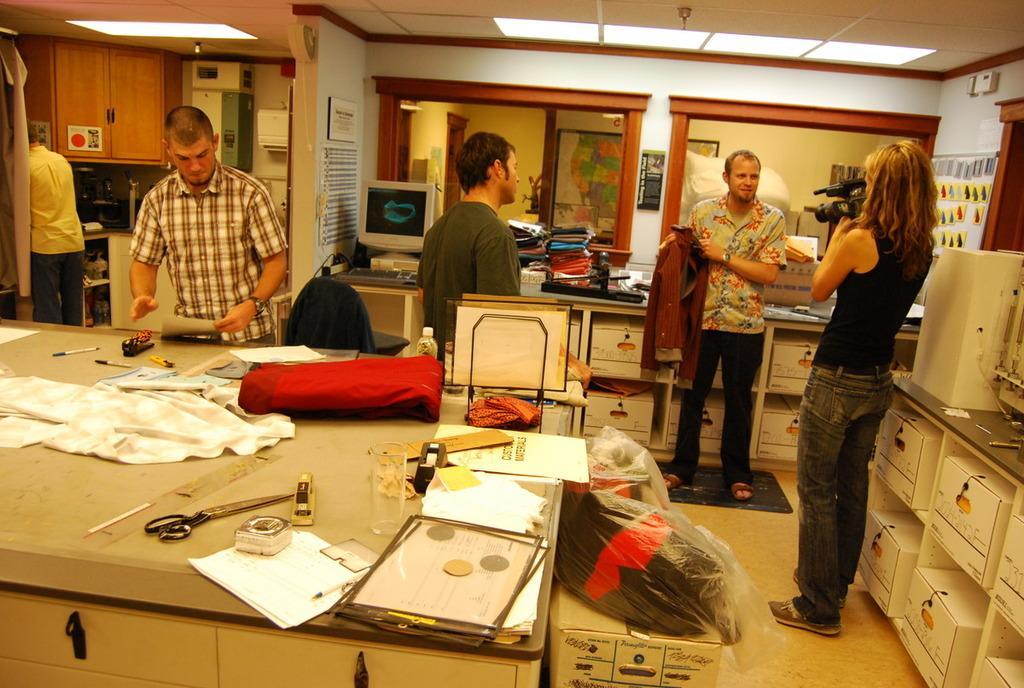In one or two sentences, can you explain what this image depicts? There is a person. He is standing in front of the table on which there are so many objects. Beside him, there is another person. He is watching at him. He is looking at the camera. The woman is holding this camera. In the background, there is mirror, monitor, clothes, boxes, and some other objects. On the left hand side, there is a woman standing and working. On the right hand side, there is a floor, boxes, desk and wall. 